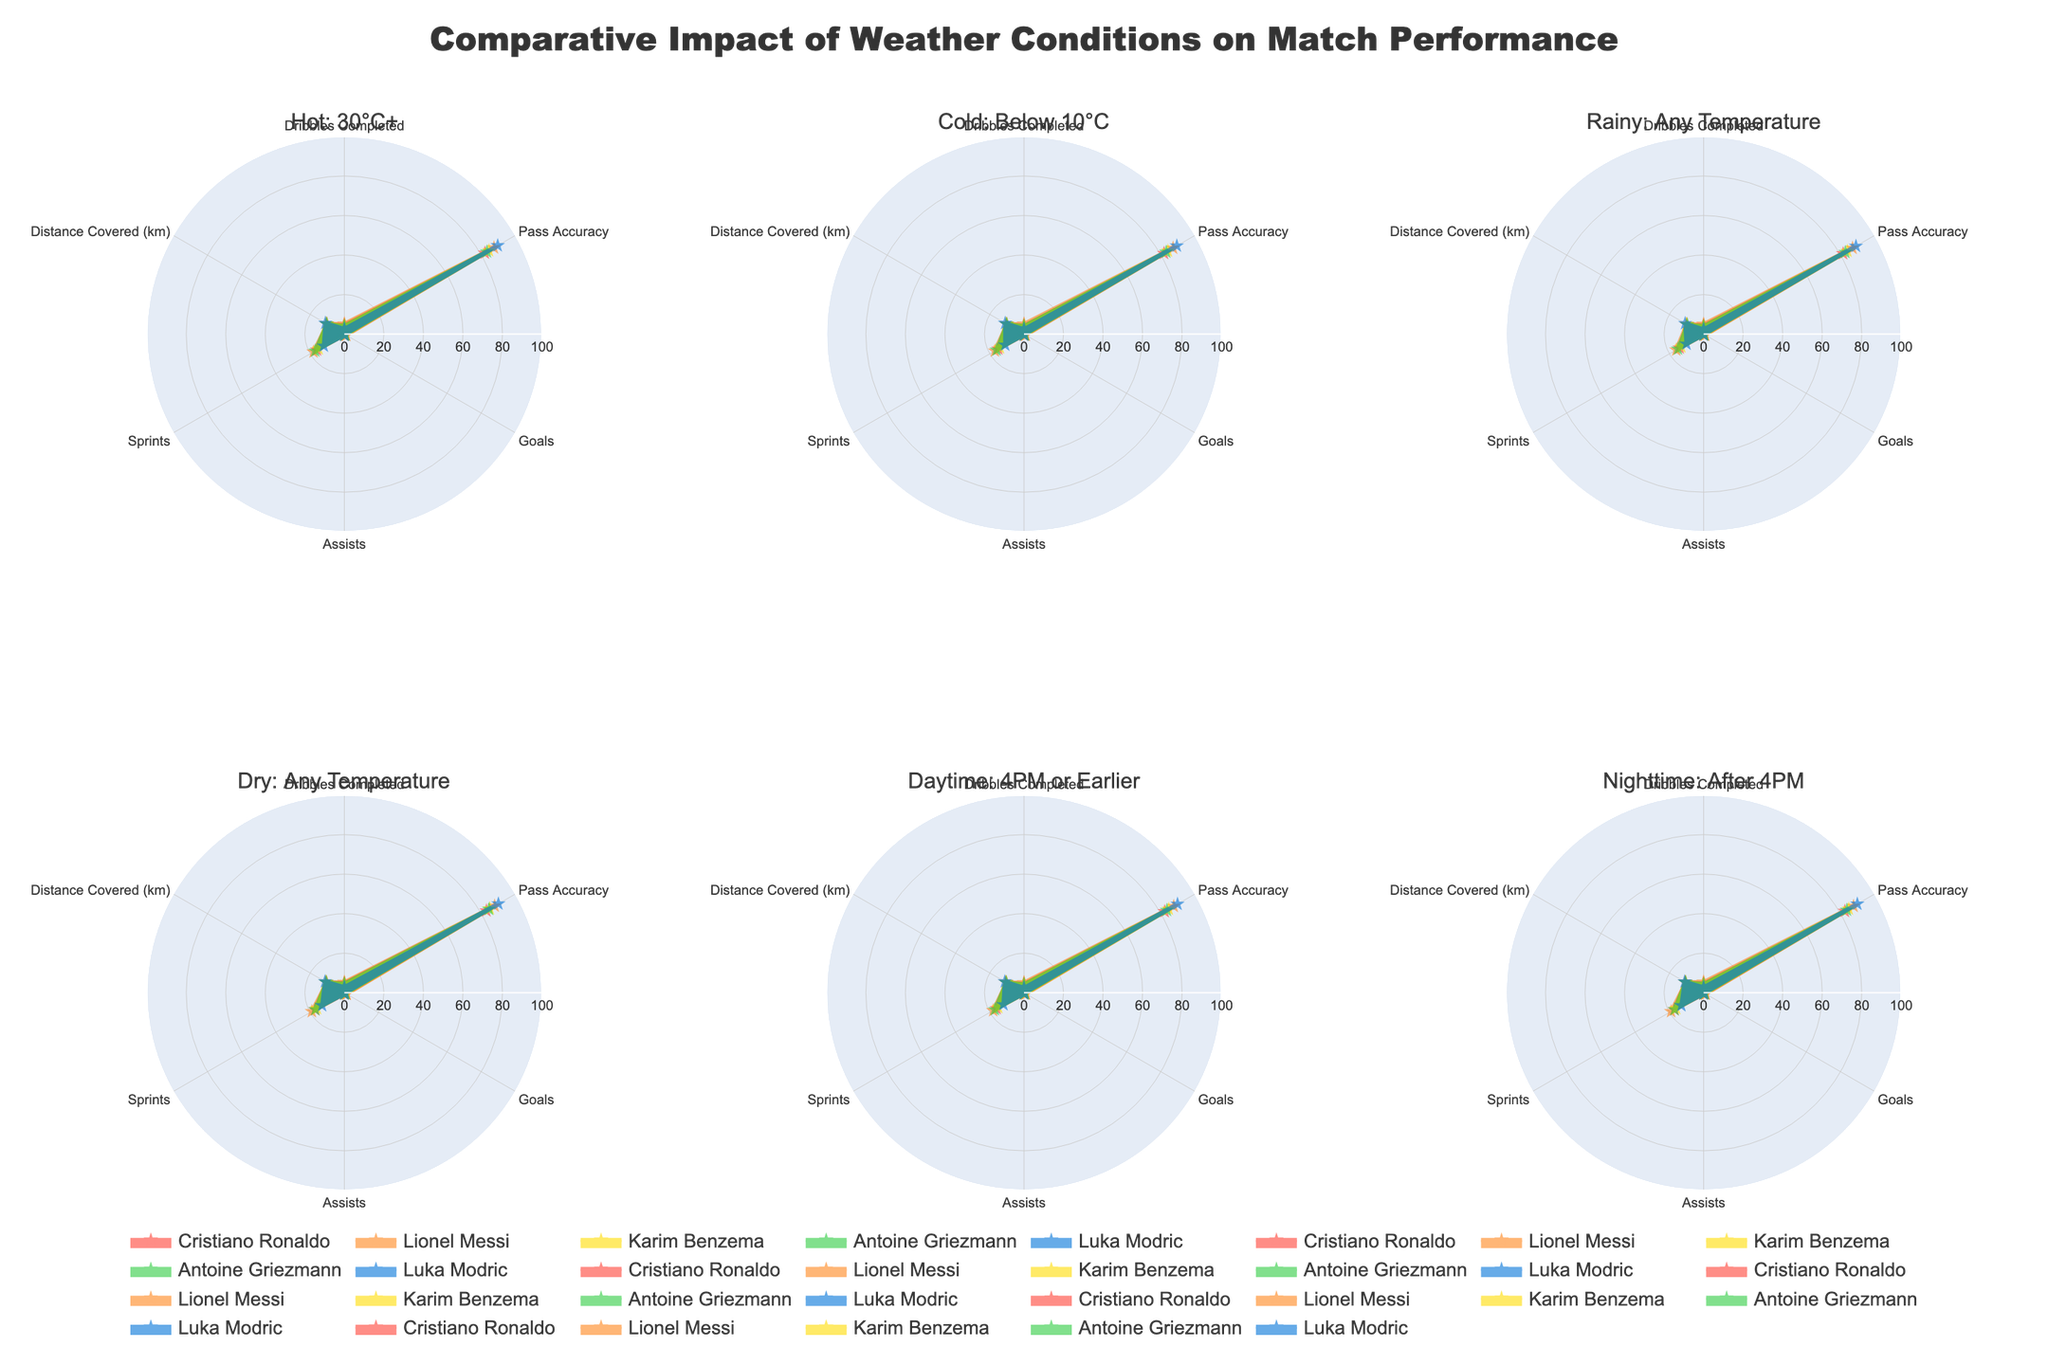How does Lionel Messi's goals per match performance compare in dry and rainy conditions? To determine Messi's goals per match performance, look at the radar chart sections for "Goals" under dry and rainy conditions. Messi scores 1.3 goals per match in dry conditions and 0.9 goals per match in rainy conditions. So, his performance is better in dry conditions.
Answer: He performs better in dry conditions What's the average number of dribbles completed by Luka Modric across all conditions? Summing up Luka Modric's dribbles completed under hot (2.6), cold (2.5), rainy (2.4), dry (2.8), daytime (2.5), and nighttime (2.7) conditions, we get a total of 15.5 dribbles. Dividing by the 6 conditions gives an average. 15.5 / 6 = 2.58
Answer: 2.58 Which player covers the most distance in nighttime matches? Refer to the radar chart section for "Distance Covered (km)" under nighttime conditions. Luka Modric shows the highest value at 11.1 km.
Answer: Luka Modric Compare Cristiano Ronaldo and Antoine Griezmann in terms of pass accuracy in hot conditions. Who performs better? Under hot conditions, Cristiano Ronaldo has a pass accuracy of 82.1, whereas Antoine Griezmann has a pass accuracy of 83.3. Antoine Griezmann performs slightly better.
Answer: Antoine Griezmann What is the difference in assists between daylight and nighttime conditions for Karim Benzema? Karim Benzema has 0.4 assists in both daylight and nighttime conditions. Difference = 0.4 - 0.4 = 0
Answer: 0 How does the number of sprints by Lionel Messi change from cold to hot conditions? Refer to the radar chart for the number of sprints under cold and hot conditions. Messi has 17 sprints in cold conditions and 18 sprints in hot conditions. Change = 18 - 17 = 1
Answer: +1 Which criterion in dry conditions does Lionel Messi outperform all other players? In the radar chart for dry conditions, look for the highest values in each criterion. Lionel Messi outperforms all other players in "Dribbles Completed," "Pass Accuracy," and "Goals."
Answer: Dribbles Completed, Pass Accuracy, Goals Does Karim Benzema perform equally well in assists under rainy and nighttime conditions? Karim Benzema has 0.2 assists in rainy conditions and 0.4 assists in nighttime conditions. They are not equal.
Answer: No What's the sum of goals scored by all players in cold conditions? Summing up the goals scored in cold conditions: Cristiano Ronaldo (0.8), Lionel Messi (1), Karim Benzema (0.6), Antoine Griezmann (0.5), Luka Modric (0.2). Total = 0.8 + 1 + 0.6 + 0.5 + 0.2 = 3.1
Answer: 3.1 